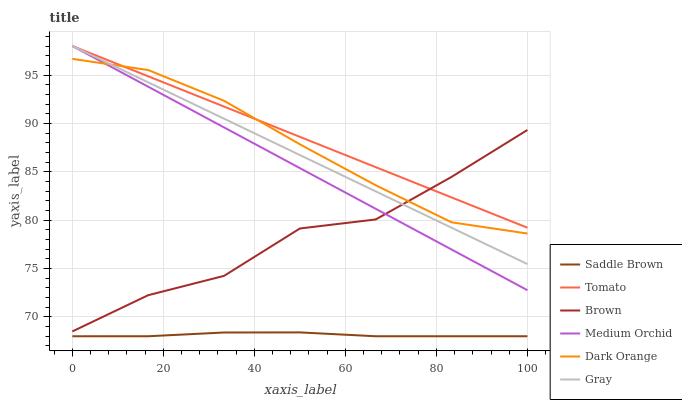Does Saddle Brown have the minimum area under the curve?
Answer yes or no. Yes. Does Tomato have the maximum area under the curve?
Answer yes or no. Yes. Does Brown have the minimum area under the curve?
Answer yes or no. No. Does Brown have the maximum area under the curve?
Answer yes or no. No. Is Gray the smoothest?
Answer yes or no. Yes. Is Brown the roughest?
Answer yes or no. Yes. Is Brown the smoothest?
Answer yes or no. No. Is Gray the roughest?
Answer yes or no. No. Does Saddle Brown have the lowest value?
Answer yes or no. Yes. Does Brown have the lowest value?
Answer yes or no. No. Does Medium Orchid have the highest value?
Answer yes or no. Yes. Does Brown have the highest value?
Answer yes or no. No. Is Saddle Brown less than Medium Orchid?
Answer yes or no. Yes. Is Medium Orchid greater than Saddle Brown?
Answer yes or no. Yes. Does Brown intersect Gray?
Answer yes or no. Yes. Is Brown less than Gray?
Answer yes or no. No. Is Brown greater than Gray?
Answer yes or no. No. Does Saddle Brown intersect Medium Orchid?
Answer yes or no. No. 